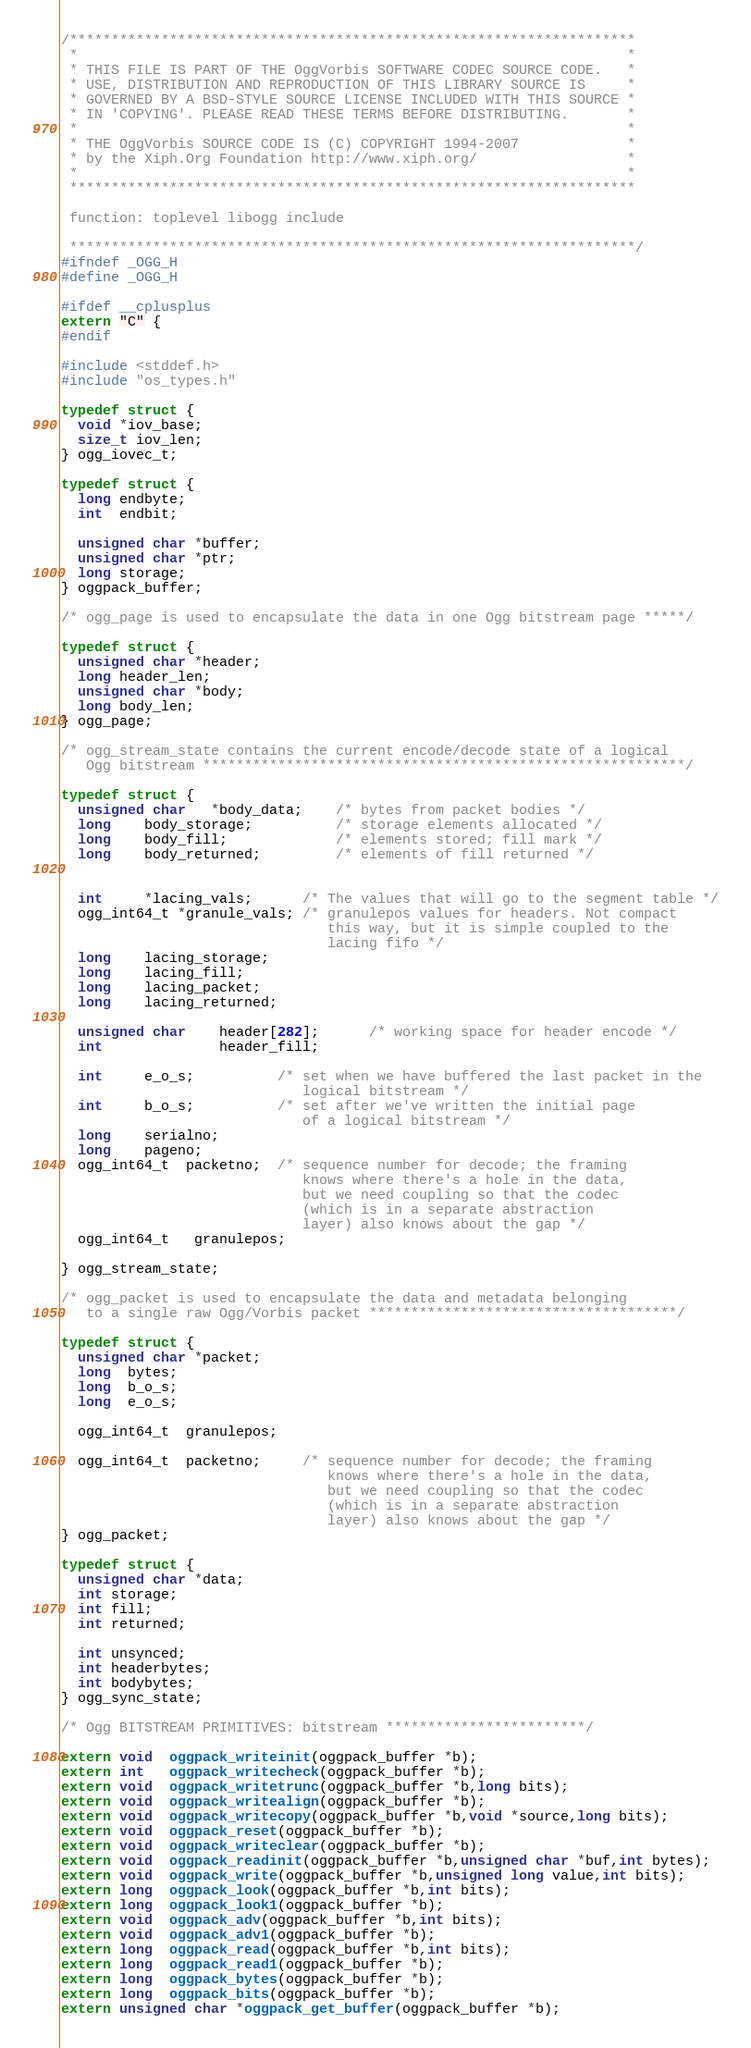<code> <loc_0><loc_0><loc_500><loc_500><_C_>/********************************************************************
 *                                                                  *
 * THIS FILE IS PART OF THE OggVorbis SOFTWARE CODEC SOURCE CODE.   *
 * USE, DISTRIBUTION AND REPRODUCTION OF THIS LIBRARY SOURCE IS     *
 * GOVERNED BY A BSD-STYLE SOURCE LICENSE INCLUDED WITH THIS SOURCE *
 * IN 'COPYING'. PLEASE READ THESE TERMS BEFORE DISTRIBUTING.       *
 *                                                                  *
 * THE OggVorbis SOURCE CODE IS (C) COPYRIGHT 1994-2007             *
 * by the Xiph.Org Foundation http://www.xiph.org/                  *
 *                                                                  *
 ********************************************************************

 function: toplevel libogg include

 ********************************************************************/
#ifndef _OGG_H
#define _OGG_H

#ifdef __cplusplus
extern "C" {
#endif

#include <stddef.h>
#include "os_types.h"

typedef struct {
  void *iov_base;
  size_t iov_len;
} ogg_iovec_t;

typedef struct {
  long endbyte;
  int  endbit;

  unsigned char *buffer;
  unsigned char *ptr;
  long storage;
} oggpack_buffer;

/* ogg_page is used to encapsulate the data in one Ogg bitstream page *****/

typedef struct {
  unsigned char *header;
  long header_len;
  unsigned char *body;
  long body_len;
} ogg_page;

/* ogg_stream_state contains the current encode/decode state of a logical
   Ogg bitstream **********************************************************/

typedef struct {
  unsigned char   *body_data;    /* bytes from packet bodies */
  long    body_storage;          /* storage elements allocated */
  long    body_fill;             /* elements stored; fill mark */
  long    body_returned;         /* elements of fill returned */


  int     *lacing_vals;      /* The values that will go to the segment table */
  ogg_int64_t *granule_vals; /* granulepos values for headers. Not compact
                                this way, but it is simple coupled to the
                                lacing fifo */
  long    lacing_storage;
  long    lacing_fill;
  long    lacing_packet;
  long    lacing_returned;

  unsigned char    header[282];      /* working space for header encode */
  int              header_fill;

  int     e_o_s;          /* set when we have buffered the last packet in the
                             logical bitstream */
  int     b_o_s;          /* set after we've written the initial page
                             of a logical bitstream */
  long    serialno;
  long    pageno;
  ogg_int64_t  packetno;  /* sequence number for decode; the framing
                             knows where there's a hole in the data,
                             but we need coupling so that the codec
                             (which is in a separate abstraction
                             layer) also knows about the gap */
  ogg_int64_t   granulepos;

} ogg_stream_state;

/* ogg_packet is used to encapsulate the data and metadata belonging
   to a single raw Ogg/Vorbis packet *************************************/

typedef struct {
  unsigned char *packet;
  long  bytes;
  long  b_o_s;
  long  e_o_s;

  ogg_int64_t  granulepos;

  ogg_int64_t  packetno;     /* sequence number for decode; the framing
                                knows where there's a hole in the data,
                                but we need coupling so that the codec
                                (which is in a separate abstraction
                                layer) also knows about the gap */
} ogg_packet;

typedef struct {
  unsigned char *data;
  int storage;
  int fill;
  int returned;

  int unsynced;
  int headerbytes;
  int bodybytes;
} ogg_sync_state;

/* Ogg BITSTREAM PRIMITIVES: bitstream ************************/

extern void  oggpack_writeinit(oggpack_buffer *b);
extern int   oggpack_writecheck(oggpack_buffer *b);
extern void  oggpack_writetrunc(oggpack_buffer *b,long bits);
extern void  oggpack_writealign(oggpack_buffer *b);
extern void  oggpack_writecopy(oggpack_buffer *b,void *source,long bits);
extern void  oggpack_reset(oggpack_buffer *b);
extern void  oggpack_writeclear(oggpack_buffer *b);
extern void  oggpack_readinit(oggpack_buffer *b,unsigned char *buf,int bytes);
extern void  oggpack_write(oggpack_buffer *b,unsigned long value,int bits);
extern long  oggpack_look(oggpack_buffer *b,int bits);
extern long  oggpack_look1(oggpack_buffer *b);
extern void  oggpack_adv(oggpack_buffer *b,int bits);
extern void  oggpack_adv1(oggpack_buffer *b);
extern long  oggpack_read(oggpack_buffer *b,int bits);
extern long  oggpack_read1(oggpack_buffer *b);
extern long  oggpack_bytes(oggpack_buffer *b);
extern long  oggpack_bits(oggpack_buffer *b);
extern unsigned char *oggpack_get_buffer(oggpack_buffer *b);
</code> 